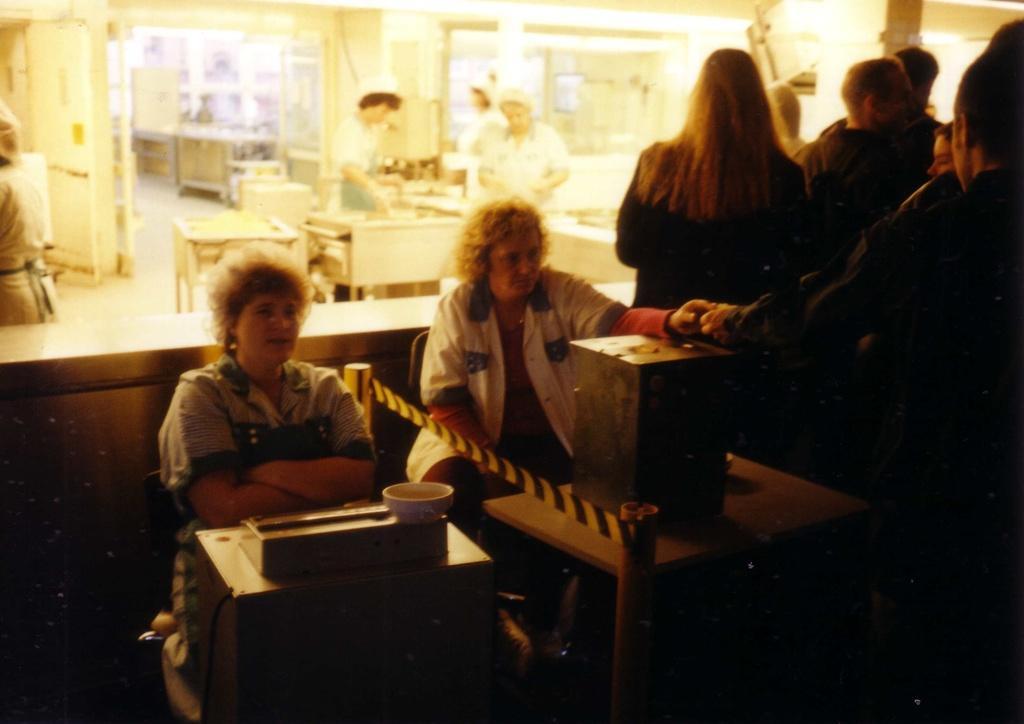Can you describe this image briefly? In this picture we can see some people are standing on the right side, there are two persons sitting on chairs in front of tables, there is a box present on this table, on the left side we can see a bowl, in the background we can see three more persons are standing. 